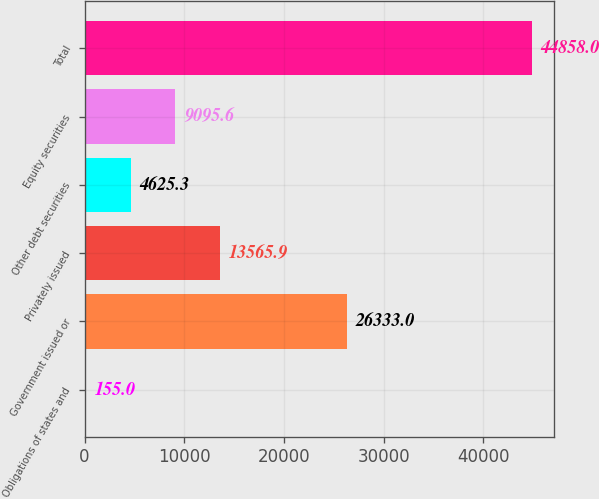Convert chart to OTSL. <chart><loc_0><loc_0><loc_500><loc_500><bar_chart><fcel>Obligations of states and<fcel>Government issued or<fcel>Privately issued<fcel>Other debt securities<fcel>Equity securities<fcel>Total<nl><fcel>155<fcel>26333<fcel>13565.9<fcel>4625.3<fcel>9095.6<fcel>44858<nl></chart> 